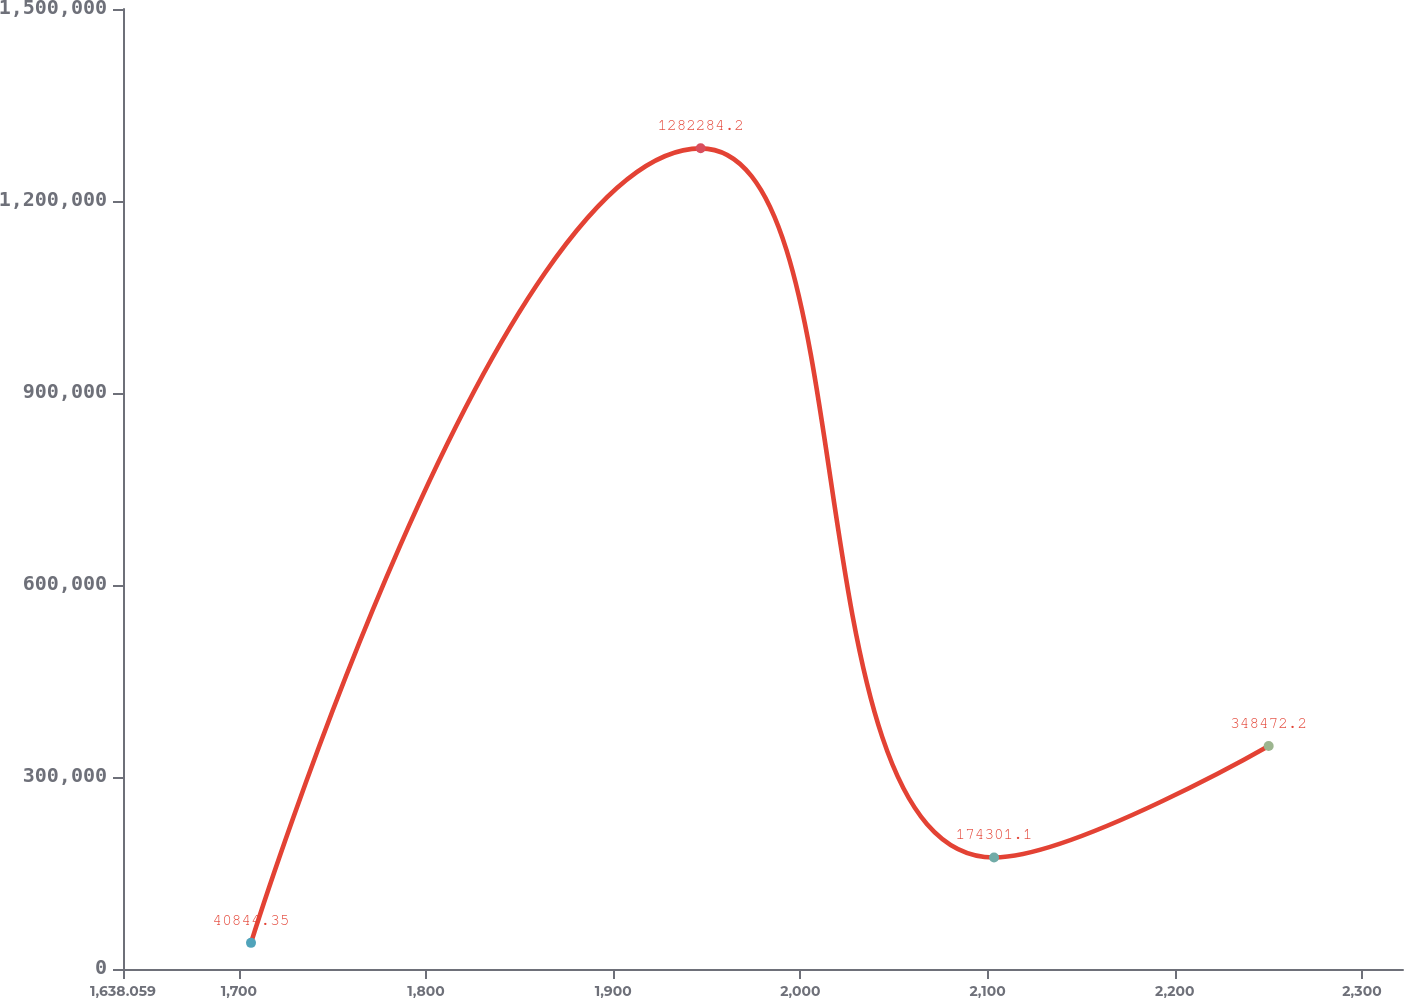Convert chart to OTSL. <chart><loc_0><loc_0><loc_500><loc_500><line_chart><ecel><fcel>(in thousands)<nl><fcel>1706.45<fcel>40844.3<nl><fcel>1946.7<fcel>1.28228e+06<nl><fcel>2103.45<fcel>174301<nl><fcel>2250.19<fcel>348472<nl><fcel>2390.36<fcel>472616<nl></chart> 